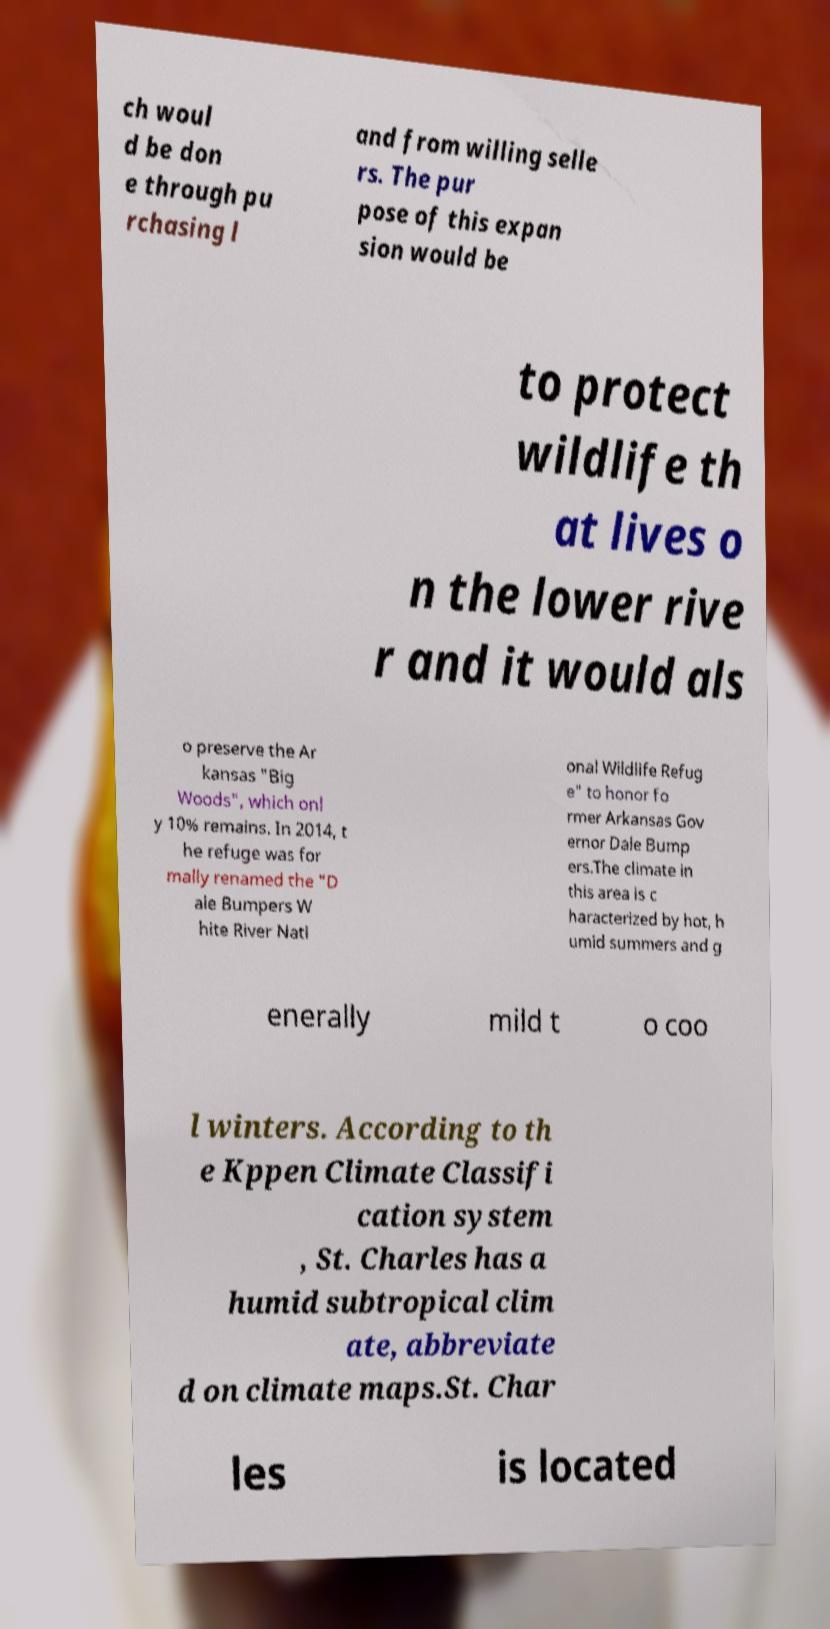Could you extract and type out the text from this image? ch woul d be don e through pu rchasing l and from willing selle rs. The pur pose of this expan sion would be to protect wildlife th at lives o n the lower rive r and it would als o preserve the Ar kansas "Big Woods", which onl y 10% remains. In 2014, t he refuge was for mally renamed the "D ale Bumpers W hite River Nati onal Wildlife Refug e" to honor fo rmer Arkansas Gov ernor Dale Bump ers.The climate in this area is c haracterized by hot, h umid summers and g enerally mild t o coo l winters. According to th e Kppen Climate Classifi cation system , St. Charles has a humid subtropical clim ate, abbreviate d on climate maps.St. Char les is located 